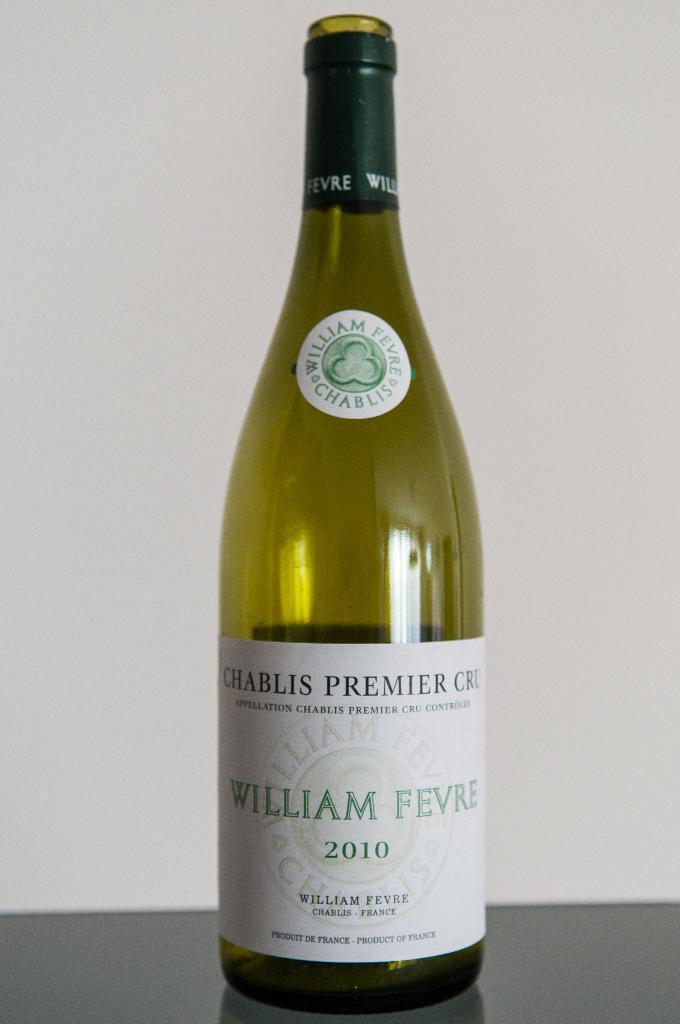Could you give a brief overview of what you see in this image? This bottle is highlighted in this picture. On this bottle there is a sticker. 